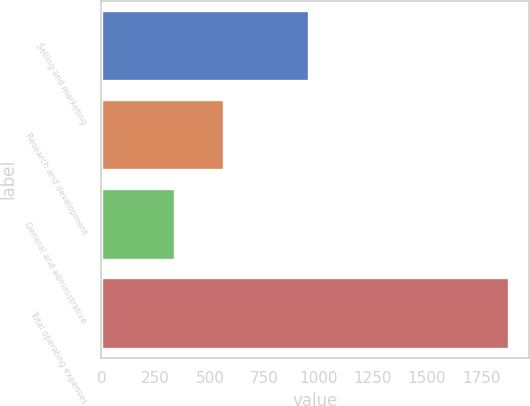<chart> <loc_0><loc_0><loc_500><loc_500><bar_chart><fcel>Selling and marketing<fcel>Research and development<fcel>General and administrative<fcel>Total operating expenses<nl><fcel>959<fcel>566<fcel>341<fcel>1877<nl></chart> 